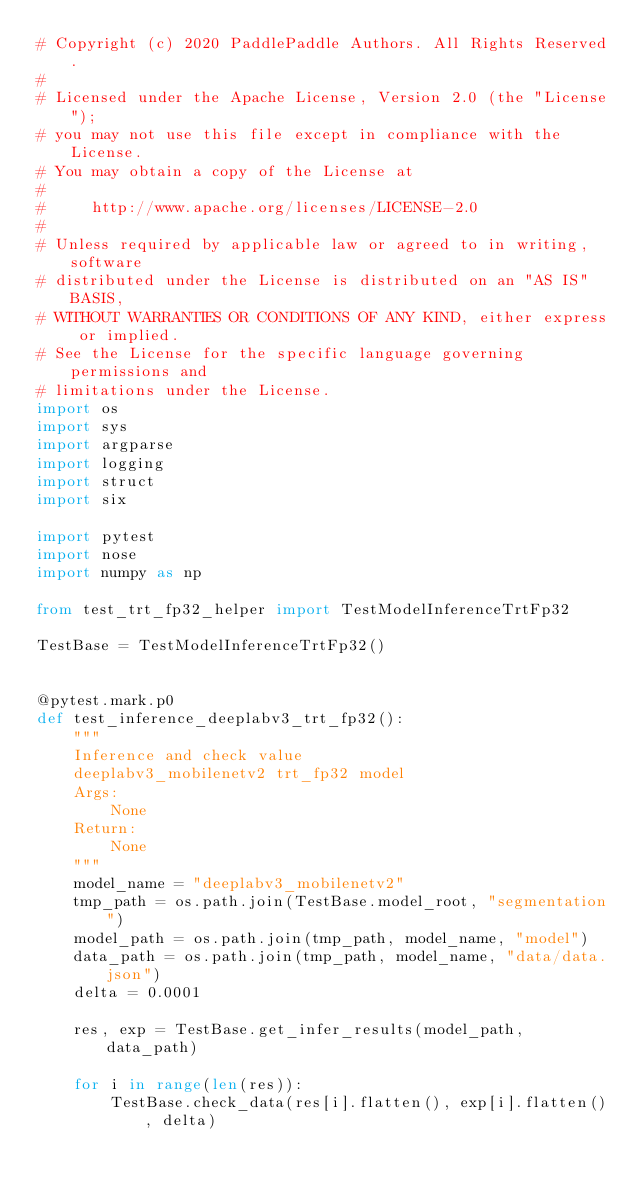Convert code to text. <code><loc_0><loc_0><loc_500><loc_500><_Python_># Copyright (c) 2020 PaddlePaddle Authors. All Rights Reserved.
#
# Licensed under the Apache License, Version 2.0 (the "License");
# you may not use this file except in compliance with the License.
# You may obtain a copy of the License at
#
#     http://www.apache.org/licenses/LICENSE-2.0
#
# Unless required by applicable law or agreed to in writing, software
# distributed under the License is distributed on an "AS IS" BASIS,
# WITHOUT WARRANTIES OR CONDITIONS OF ANY KIND, either express or implied.
# See the License for the specific language governing permissions and
# limitations under the License.
import os
import sys
import argparse
import logging
import struct
import six

import pytest
import nose
import numpy as np

from test_trt_fp32_helper import TestModelInferenceTrtFp32

TestBase = TestModelInferenceTrtFp32()


@pytest.mark.p0
def test_inference_deeplabv3_trt_fp32():
    """
    Inference and check value
    deeplabv3_mobilenetv2 trt_fp32 model
    Args:
        None
    Return:
        None
    """
    model_name = "deeplabv3_mobilenetv2"
    tmp_path = os.path.join(TestBase.model_root, "segmentation")
    model_path = os.path.join(tmp_path, model_name, "model")
    data_path = os.path.join(tmp_path, model_name, "data/data.json")
    delta = 0.0001

    res, exp = TestBase.get_infer_results(model_path, data_path)

    for i in range(len(res)):
        TestBase.check_data(res[i].flatten(), exp[i].flatten(), delta)
</code> 